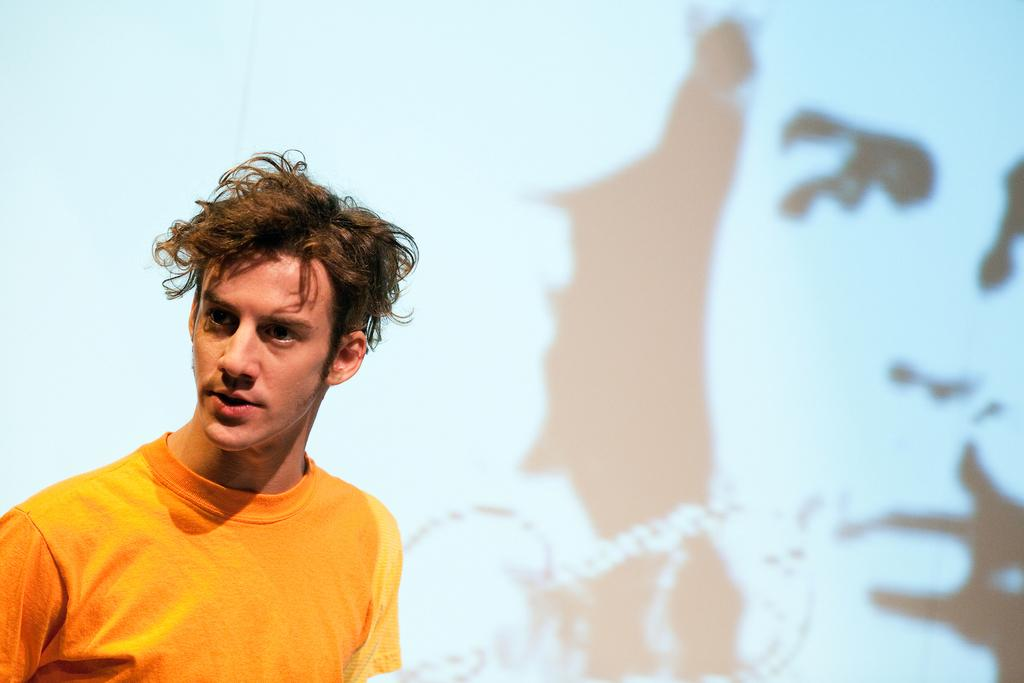What is the main subject of the image? There is a man in the image. Can you describe any other elements in the background of the image? There appears to be a hoarding of a man in the background of the image. How does the man in the image stitch the picture? There is no picture present in the image, nor is there any indication that the man is stitching anything. 